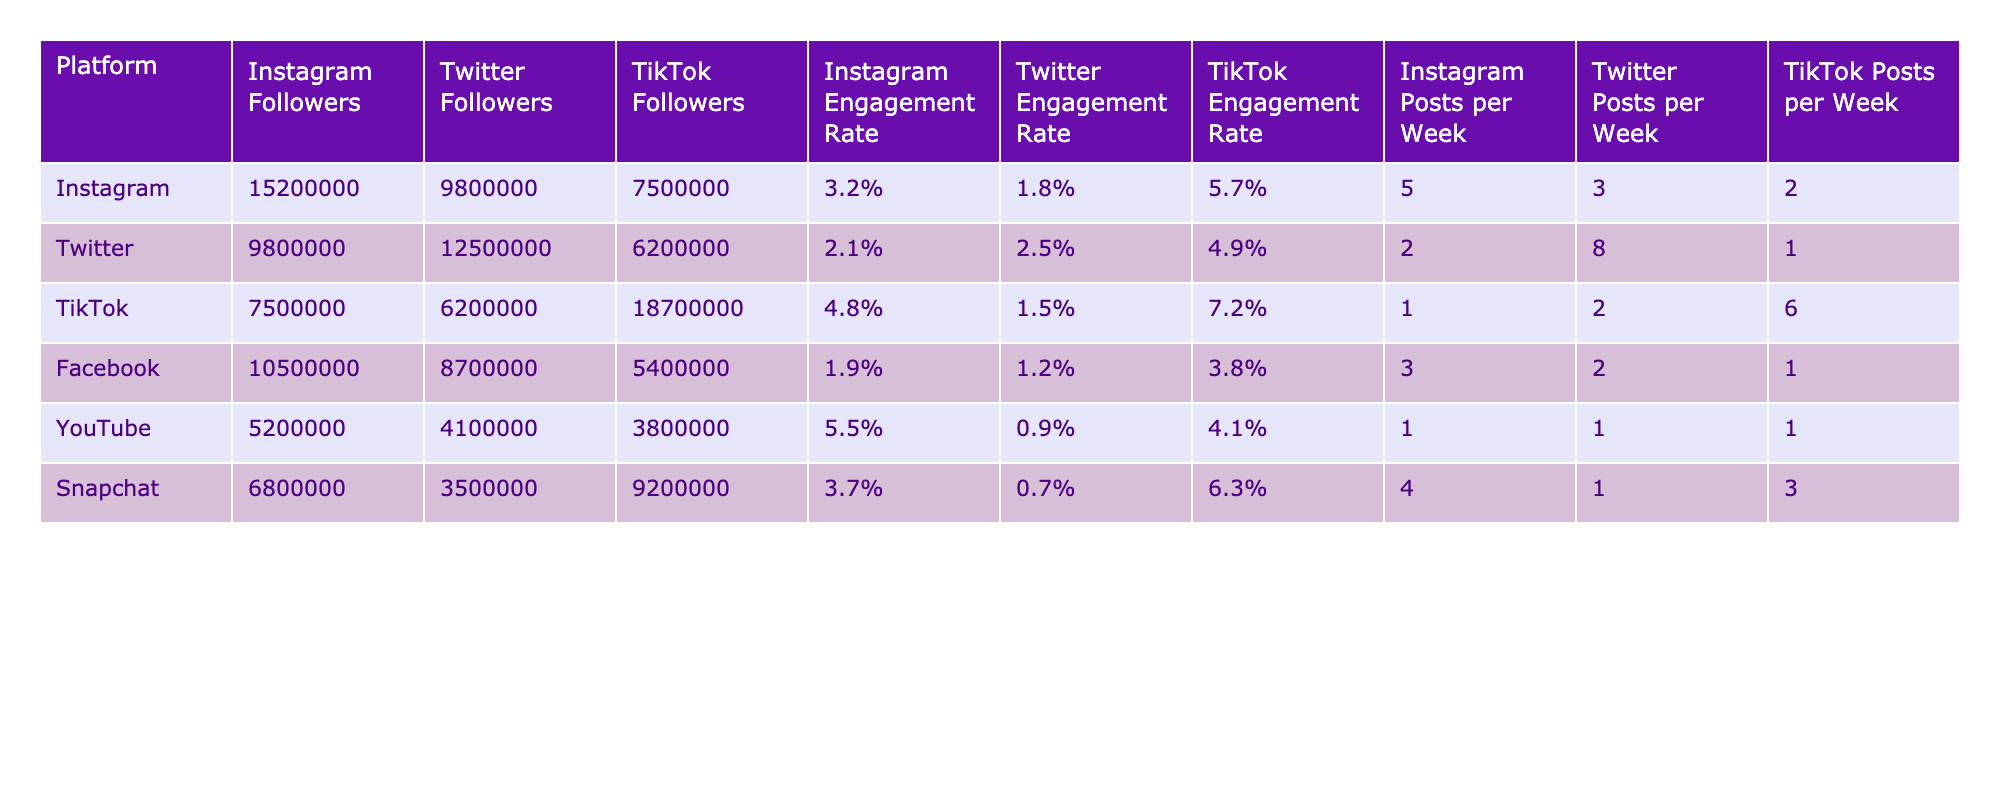What is the Instagram Engagement Rate for TikTok? Referring to the table, the TikTok row shows an Instagram Engagement Rate of 4.8%.
Answer: 4.8% Which platform has the highest number of followers on Twitter? Looking at the Twitter Followers column, Twitter has 12,500,000 followers, which is higher than all other platforms.
Answer: Twitter What is the average number of posts per week across all platforms on Instagram? To find the average, we add the posts per week (5 + 2 + 1 + 3 + 1 + 4 = 16) and divide by 6 (the number of platforms), resulting in an average of 2.67.
Answer: 2.67 Which platform has the highest TikTok Engagement Rate? By examining the TikTok Engagement Rate column, it can be seen that TikTok has 7.2%, which is the highest compared to other platforms.
Answer: TikTok Is the Twitter Engagement Rate higher than the Facebook Engagement Rate? Looking at the respective Engagement Rates, Twitter has 2.5% while Facebook has 1.2%, thus confirming that Twitter's rate is indeed higher.
Answer: Yes What is the difference between the Instagram Followers and TikTok Followers for Facebook? For Facebook, Instagram Followers are 10,500,000 and TikTok Followers are 5,400,000. The difference is calculated as 10,500,000 - 5,400,000 = 5,100,000.
Answer: 5,100,000 Which platform has the lowest engagement rate on Twitter? In the Twitter Engagement Rate column, Facebook has the lowest rate at 1.2%.
Answer: Facebook How many more Instagram Followers does Snapchat have compared to YouTube? The Instagram Followers for Snapchat is 6,800,000 and for YouTube is 5,200,000. The difference is calculated as 6,800,000 - 5,200,000 = 1,600,000.
Answer: 1,600,000 What is the combined engagement rate for Instagram and TikTok? To find the combined engagement rate, we add the two rates, which are 3.2% (Instagram) and 4.8% (TikTok), totaling 8%.
Answer: 8% Are there more Instagram Followers on Instagram than on Snapchat? Instagram has 15,200,000 followers while Snapchat has 6,800,000 followers, confirming that Instagram has more followers.
Answer: Yes 